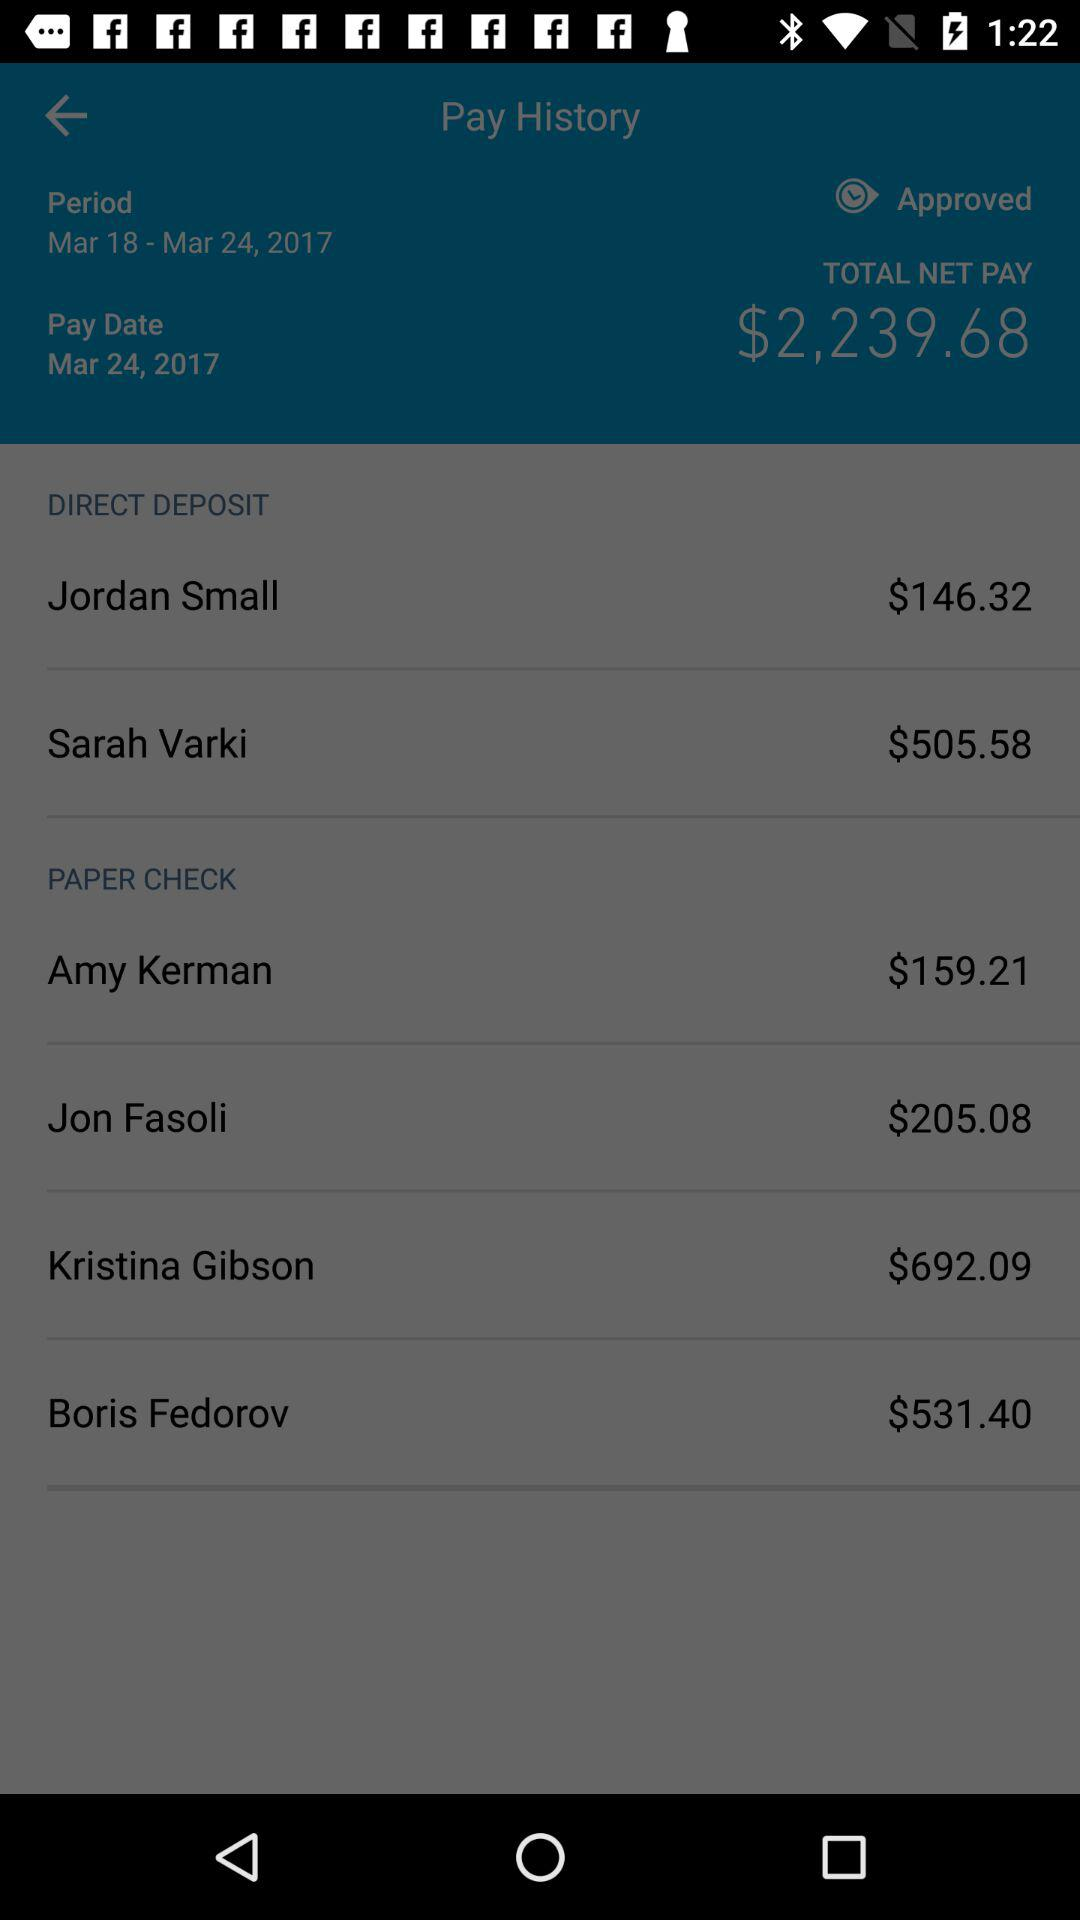What is the status of the jordan small price?
When the provided information is insufficient, respond with <no answer>. <no answer> 